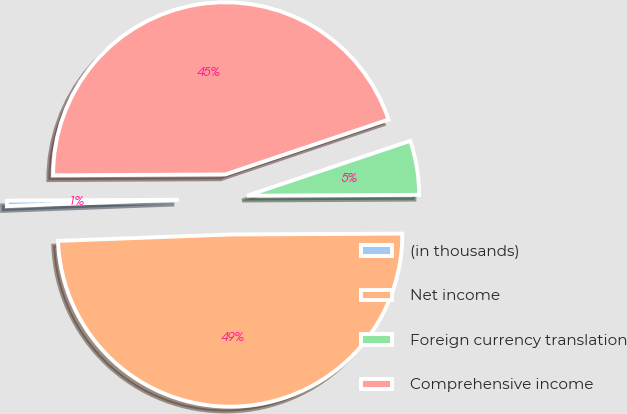Convert chart. <chart><loc_0><loc_0><loc_500><loc_500><pie_chart><fcel>(in thousands)<fcel>Net income<fcel>Foreign currency translation<fcel>Comprehensive income<nl><fcel>0.51%<fcel>49.49%<fcel>5.08%<fcel>44.92%<nl></chart> 